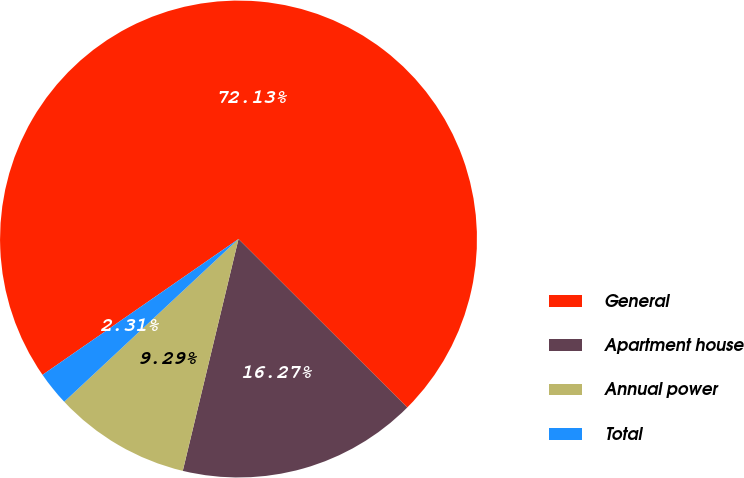Convert chart to OTSL. <chart><loc_0><loc_0><loc_500><loc_500><pie_chart><fcel>General<fcel>Apartment house<fcel>Annual power<fcel>Total<nl><fcel>72.13%<fcel>16.27%<fcel>9.29%<fcel>2.31%<nl></chart> 